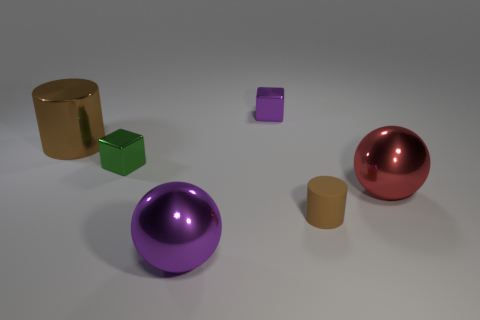Subtract all brown balls. Subtract all gray blocks. How many balls are left? 2 Add 1 small cyan metal things. How many objects exist? 7 Subtract all blocks. How many objects are left? 4 Add 5 big blue rubber cylinders. How many big blue rubber cylinders exist? 5 Subtract 0 blue balls. How many objects are left? 6 Subtract all big spheres. Subtract all brown matte objects. How many objects are left? 3 Add 3 metal spheres. How many metal spheres are left? 5 